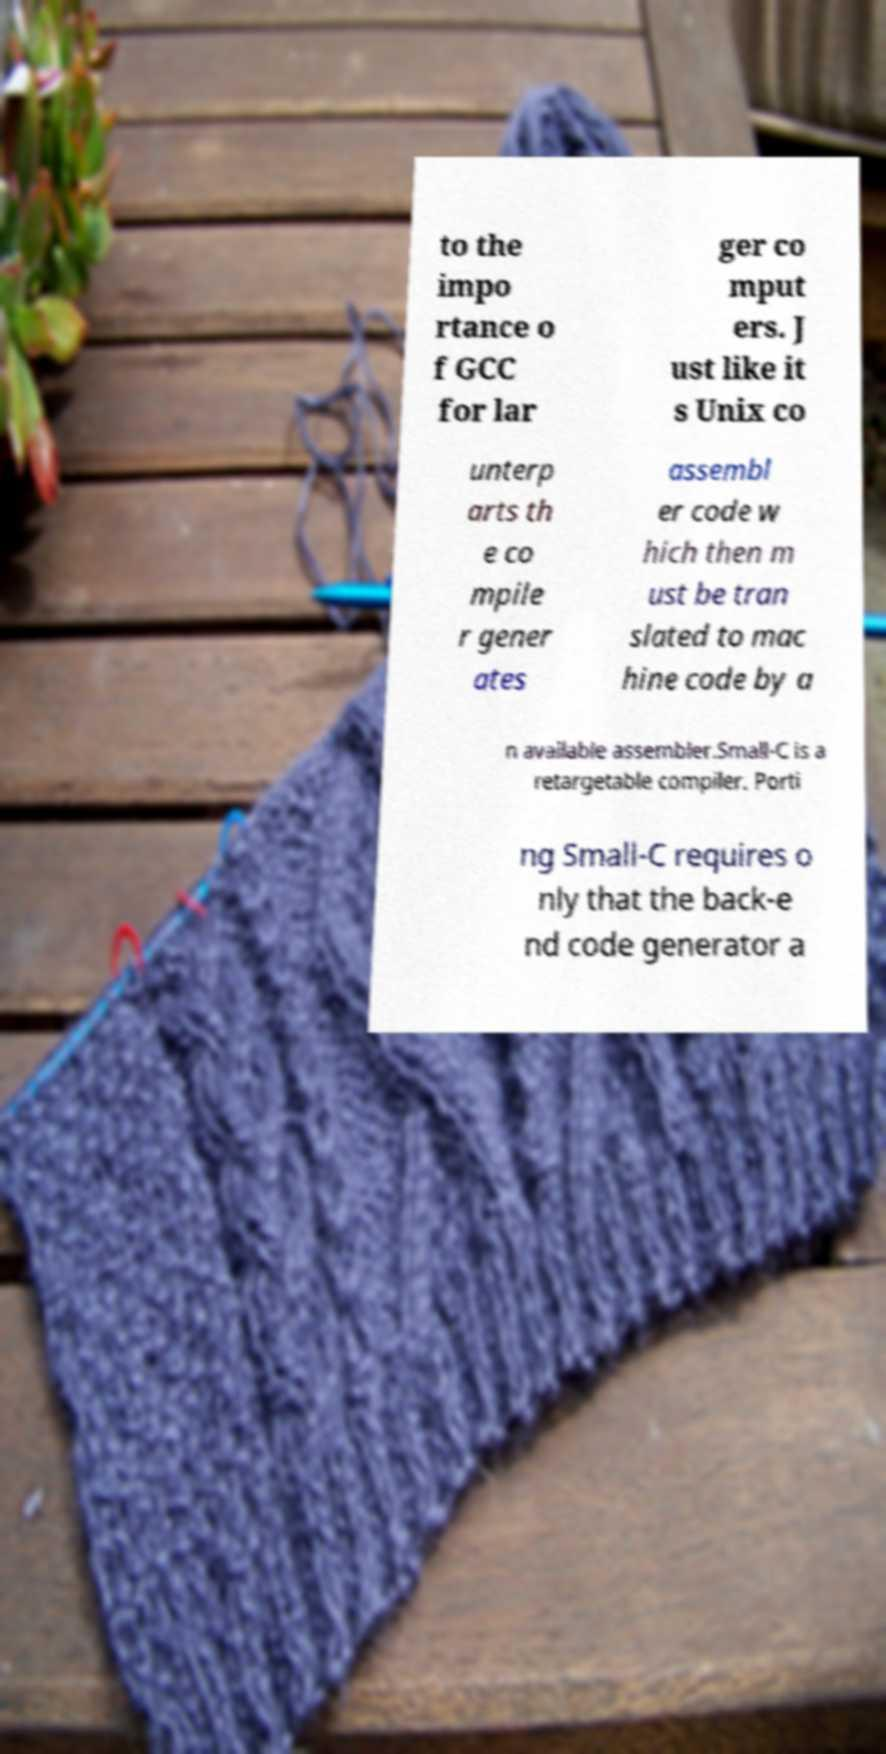Please identify and transcribe the text found in this image. to the impo rtance o f GCC for lar ger co mput ers. J ust like it s Unix co unterp arts th e co mpile r gener ates assembl er code w hich then m ust be tran slated to mac hine code by a n available assembler.Small-C is a retargetable compiler. Porti ng Small-C requires o nly that the back-e nd code generator a 